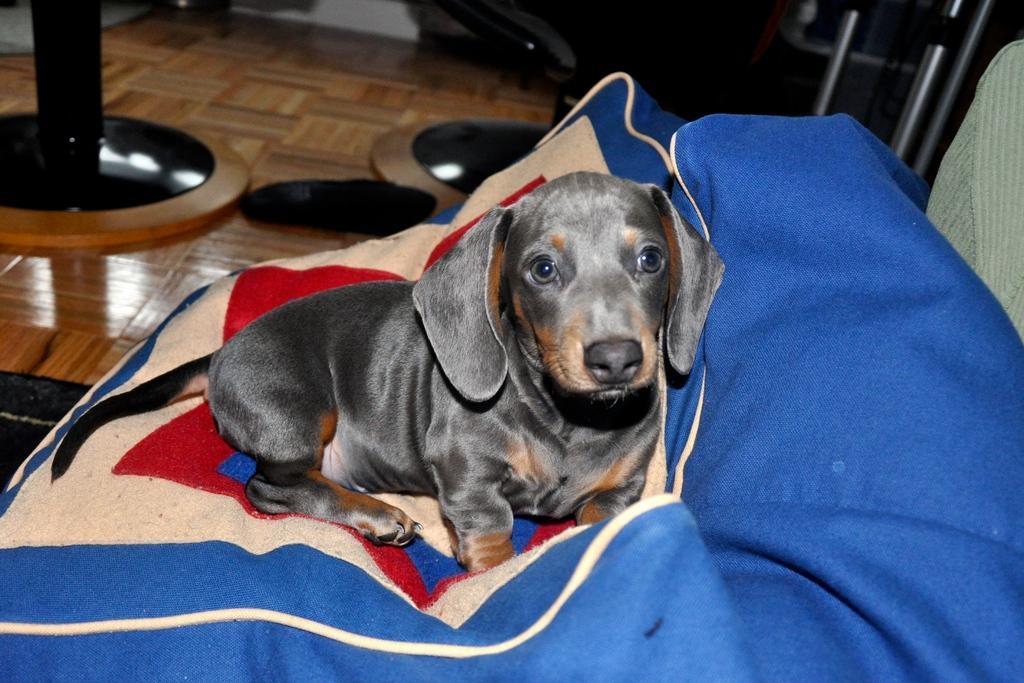Could you give a brief overview of what you see in this image? In this image there is a dog sitting on a couch. Behind it there is a floor. The floor is furnished with wood. There are stands on the floor. 